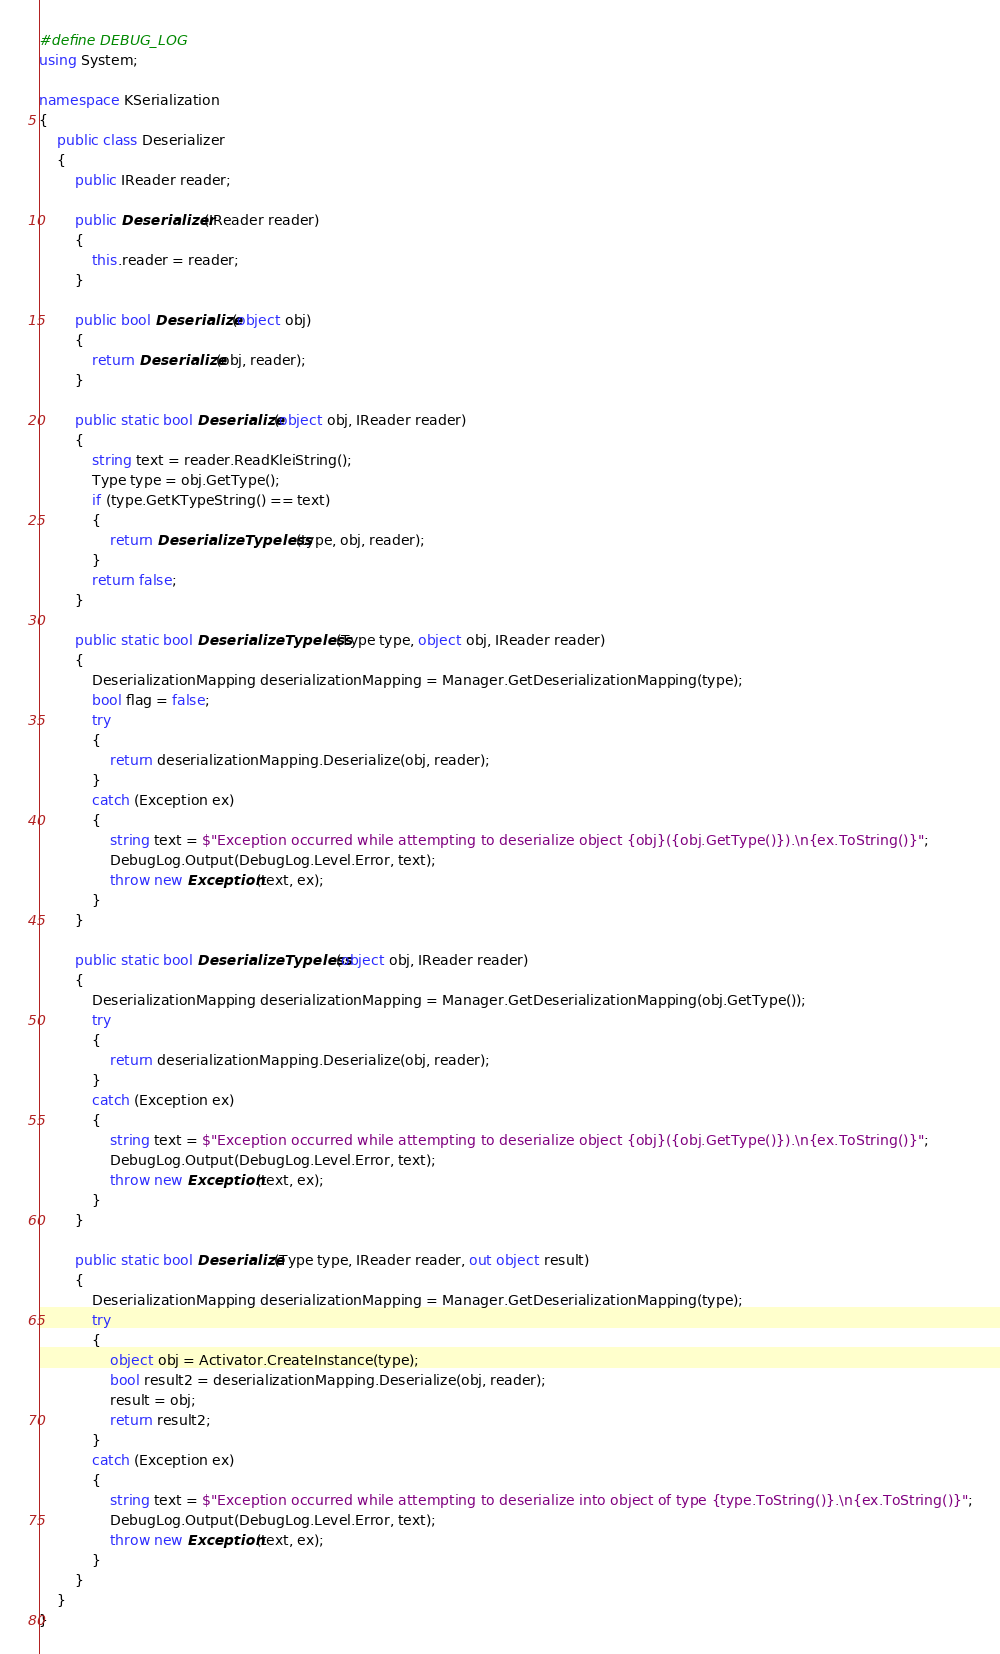Convert code to text. <code><loc_0><loc_0><loc_500><loc_500><_C#_>#define DEBUG_LOG
using System;

namespace KSerialization
{
	public class Deserializer
	{
		public IReader reader;

		public Deserializer(IReader reader)
		{
			this.reader = reader;
		}

		public bool Deserialize(object obj)
		{
			return Deserialize(obj, reader);
		}

		public static bool Deserialize(object obj, IReader reader)
		{
			string text = reader.ReadKleiString();
			Type type = obj.GetType();
			if (type.GetKTypeString() == text)
			{
				return DeserializeTypeless(type, obj, reader);
			}
			return false;
		}

		public static bool DeserializeTypeless(Type type, object obj, IReader reader)
		{
			DeserializationMapping deserializationMapping = Manager.GetDeserializationMapping(type);
			bool flag = false;
			try
			{
				return deserializationMapping.Deserialize(obj, reader);
			}
			catch (Exception ex)
			{
				string text = $"Exception occurred while attempting to deserialize object {obj}({obj.GetType()}).\n{ex.ToString()}";
				DebugLog.Output(DebugLog.Level.Error, text);
				throw new Exception(text, ex);
			}
		}

		public static bool DeserializeTypeless(object obj, IReader reader)
		{
			DeserializationMapping deserializationMapping = Manager.GetDeserializationMapping(obj.GetType());
			try
			{
				return deserializationMapping.Deserialize(obj, reader);
			}
			catch (Exception ex)
			{
				string text = $"Exception occurred while attempting to deserialize object {obj}({obj.GetType()}).\n{ex.ToString()}";
				DebugLog.Output(DebugLog.Level.Error, text);
				throw new Exception(text, ex);
			}
		}

		public static bool Deserialize(Type type, IReader reader, out object result)
		{
			DeserializationMapping deserializationMapping = Manager.GetDeserializationMapping(type);
			try
			{
				object obj = Activator.CreateInstance(type);
				bool result2 = deserializationMapping.Deserialize(obj, reader);
				result = obj;
				return result2;
			}
			catch (Exception ex)
			{
				string text = $"Exception occurred while attempting to deserialize into object of type {type.ToString()}.\n{ex.ToString()}";
				DebugLog.Output(DebugLog.Level.Error, text);
				throw new Exception(text, ex);
			}
		}
	}
}
</code> 